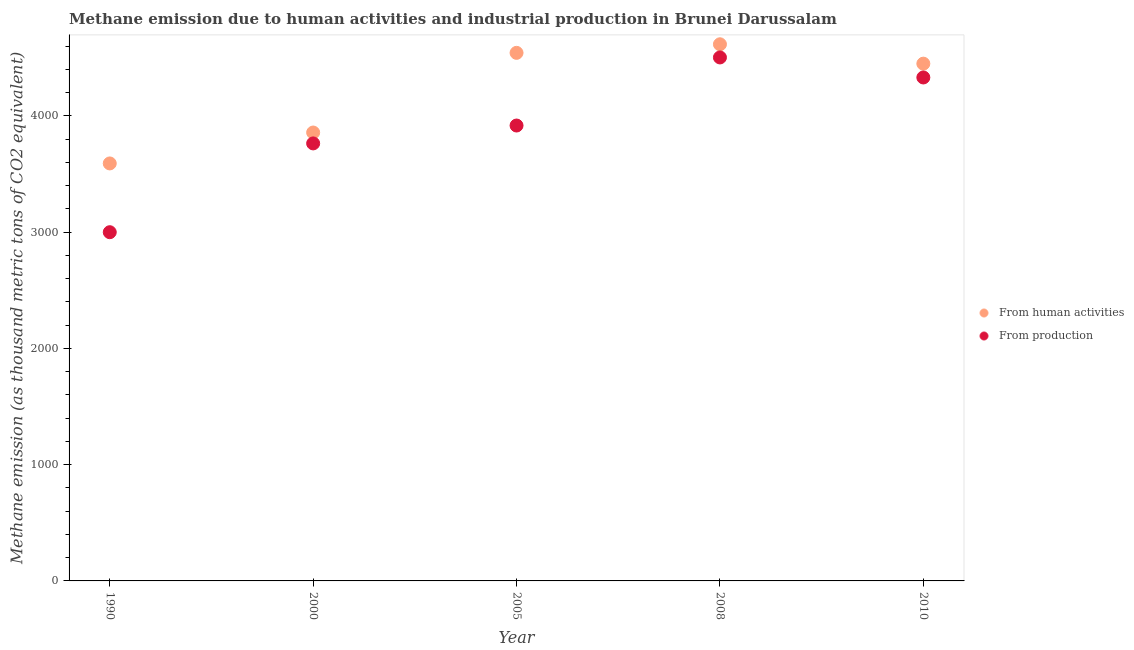How many different coloured dotlines are there?
Your response must be concise. 2. What is the amount of emissions from human activities in 2005?
Your answer should be compact. 4543.3. Across all years, what is the maximum amount of emissions from human activities?
Provide a succinct answer. 4617.1. Across all years, what is the minimum amount of emissions from human activities?
Give a very brief answer. 3591.9. In which year was the amount of emissions from human activities maximum?
Your answer should be very brief. 2008. What is the total amount of emissions generated from industries in the graph?
Offer a very short reply. 1.95e+04. What is the difference between the amount of emissions from human activities in 2000 and that in 2010?
Provide a short and direct response. -592.6. What is the difference between the amount of emissions from human activities in 2010 and the amount of emissions generated from industries in 1990?
Offer a terse response. 1450.2. What is the average amount of emissions from human activities per year?
Your answer should be very brief. 4212.1. In the year 1990, what is the difference between the amount of emissions from human activities and amount of emissions generated from industries?
Make the answer very short. 591.7. What is the ratio of the amount of emissions generated from industries in 2000 to that in 2010?
Provide a succinct answer. 0.87. Is the amount of emissions from human activities in 2000 less than that in 2010?
Provide a short and direct response. Yes. Is the difference between the amount of emissions from human activities in 2000 and 2008 greater than the difference between the amount of emissions generated from industries in 2000 and 2008?
Offer a very short reply. No. What is the difference between the highest and the second highest amount of emissions generated from industries?
Your response must be concise. 172.3. What is the difference between the highest and the lowest amount of emissions from human activities?
Offer a terse response. 1025.2. In how many years, is the amount of emissions generated from industries greater than the average amount of emissions generated from industries taken over all years?
Offer a very short reply. 3. Does the amount of emissions generated from industries monotonically increase over the years?
Provide a succinct answer. No. Is the amount of emissions from human activities strictly greater than the amount of emissions generated from industries over the years?
Keep it short and to the point. Yes. How many dotlines are there?
Your answer should be compact. 2. What is the difference between two consecutive major ticks on the Y-axis?
Your response must be concise. 1000. Does the graph contain grids?
Ensure brevity in your answer.  No. What is the title of the graph?
Offer a very short reply. Methane emission due to human activities and industrial production in Brunei Darussalam. Does "GDP at market prices" appear as one of the legend labels in the graph?
Make the answer very short. No. What is the label or title of the Y-axis?
Keep it short and to the point. Methane emission (as thousand metric tons of CO2 equivalent). What is the Methane emission (as thousand metric tons of CO2 equivalent) in From human activities in 1990?
Offer a terse response. 3591.9. What is the Methane emission (as thousand metric tons of CO2 equivalent) in From production in 1990?
Ensure brevity in your answer.  3000.2. What is the Methane emission (as thousand metric tons of CO2 equivalent) of From human activities in 2000?
Give a very brief answer. 3857.8. What is the Methane emission (as thousand metric tons of CO2 equivalent) in From production in 2000?
Provide a short and direct response. 3764.1. What is the Methane emission (as thousand metric tons of CO2 equivalent) of From human activities in 2005?
Offer a terse response. 4543.3. What is the Methane emission (as thousand metric tons of CO2 equivalent) in From production in 2005?
Make the answer very short. 3918. What is the Methane emission (as thousand metric tons of CO2 equivalent) of From human activities in 2008?
Make the answer very short. 4617.1. What is the Methane emission (as thousand metric tons of CO2 equivalent) of From production in 2008?
Offer a terse response. 4503.7. What is the Methane emission (as thousand metric tons of CO2 equivalent) in From human activities in 2010?
Your answer should be very brief. 4450.4. What is the Methane emission (as thousand metric tons of CO2 equivalent) in From production in 2010?
Give a very brief answer. 4331.4. Across all years, what is the maximum Methane emission (as thousand metric tons of CO2 equivalent) of From human activities?
Your response must be concise. 4617.1. Across all years, what is the maximum Methane emission (as thousand metric tons of CO2 equivalent) of From production?
Ensure brevity in your answer.  4503.7. Across all years, what is the minimum Methane emission (as thousand metric tons of CO2 equivalent) in From human activities?
Offer a very short reply. 3591.9. Across all years, what is the minimum Methane emission (as thousand metric tons of CO2 equivalent) in From production?
Ensure brevity in your answer.  3000.2. What is the total Methane emission (as thousand metric tons of CO2 equivalent) in From human activities in the graph?
Offer a very short reply. 2.11e+04. What is the total Methane emission (as thousand metric tons of CO2 equivalent) of From production in the graph?
Offer a very short reply. 1.95e+04. What is the difference between the Methane emission (as thousand metric tons of CO2 equivalent) of From human activities in 1990 and that in 2000?
Give a very brief answer. -265.9. What is the difference between the Methane emission (as thousand metric tons of CO2 equivalent) of From production in 1990 and that in 2000?
Make the answer very short. -763.9. What is the difference between the Methane emission (as thousand metric tons of CO2 equivalent) in From human activities in 1990 and that in 2005?
Provide a succinct answer. -951.4. What is the difference between the Methane emission (as thousand metric tons of CO2 equivalent) of From production in 1990 and that in 2005?
Make the answer very short. -917.8. What is the difference between the Methane emission (as thousand metric tons of CO2 equivalent) in From human activities in 1990 and that in 2008?
Ensure brevity in your answer.  -1025.2. What is the difference between the Methane emission (as thousand metric tons of CO2 equivalent) in From production in 1990 and that in 2008?
Make the answer very short. -1503.5. What is the difference between the Methane emission (as thousand metric tons of CO2 equivalent) of From human activities in 1990 and that in 2010?
Your response must be concise. -858.5. What is the difference between the Methane emission (as thousand metric tons of CO2 equivalent) in From production in 1990 and that in 2010?
Ensure brevity in your answer.  -1331.2. What is the difference between the Methane emission (as thousand metric tons of CO2 equivalent) of From human activities in 2000 and that in 2005?
Your answer should be compact. -685.5. What is the difference between the Methane emission (as thousand metric tons of CO2 equivalent) of From production in 2000 and that in 2005?
Give a very brief answer. -153.9. What is the difference between the Methane emission (as thousand metric tons of CO2 equivalent) of From human activities in 2000 and that in 2008?
Your answer should be compact. -759.3. What is the difference between the Methane emission (as thousand metric tons of CO2 equivalent) of From production in 2000 and that in 2008?
Provide a short and direct response. -739.6. What is the difference between the Methane emission (as thousand metric tons of CO2 equivalent) of From human activities in 2000 and that in 2010?
Your answer should be compact. -592.6. What is the difference between the Methane emission (as thousand metric tons of CO2 equivalent) of From production in 2000 and that in 2010?
Your answer should be very brief. -567.3. What is the difference between the Methane emission (as thousand metric tons of CO2 equivalent) in From human activities in 2005 and that in 2008?
Provide a short and direct response. -73.8. What is the difference between the Methane emission (as thousand metric tons of CO2 equivalent) in From production in 2005 and that in 2008?
Your answer should be very brief. -585.7. What is the difference between the Methane emission (as thousand metric tons of CO2 equivalent) in From human activities in 2005 and that in 2010?
Make the answer very short. 92.9. What is the difference between the Methane emission (as thousand metric tons of CO2 equivalent) in From production in 2005 and that in 2010?
Offer a very short reply. -413.4. What is the difference between the Methane emission (as thousand metric tons of CO2 equivalent) in From human activities in 2008 and that in 2010?
Make the answer very short. 166.7. What is the difference between the Methane emission (as thousand metric tons of CO2 equivalent) in From production in 2008 and that in 2010?
Your response must be concise. 172.3. What is the difference between the Methane emission (as thousand metric tons of CO2 equivalent) of From human activities in 1990 and the Methane emission (as thousand metric tons of CO2 equivalent) of From production in 2000?
Your response must be concise. -172.2. What is the difference between the Methane emission (as thousand metric tons of CO2 equivalent) of From human activities in 1990 and the Methane emission (as thousand metric tons of CO2 equivalent) of From production in 2005?
Offer a very short reply. -326.1. What is the difference between the Methane emission (as thousand metric tons of CO2 equivalent) in From human activities in 1990 and the Methane emission (as thousand metric tons of CO2 equivalent) in From production in 2008?
Provide a short and direct response. -911.8. What is the difference between the Methane emission (as thousand metric tons of CO2 equivalent) in From human activities in 1990 and the Methane emission (as thousand metric tons of CO2 equivalent) in From production in 2010?
Your answer should be compact. -739.5. What is the difference between the Methane emission (as thousand metric tons of CO2 equivalent) of From human activities in 2000 and the Methane emission (as thousand metric tons of CO2 equivalent) of From production in 2005?
Make the answer very short. -60.2. What is the difference between the Methane emission (as thousand metric tons of CO2 equivalent) of From human activities in 2000 and the Methane emission (as thousand metric tons of CO2 equivalent) of From production in 2008?
Offer a terse response. -645.9. What is the difference between the Methane emission (as thousand metric tons of CO2 equivalent) in From human activities in 2000 and the Methane emission (as thousand metric tons of CO2 equivalent) in From production in 2010?
Ensure brevity in your answer.  -473.6. What is the difference between the Methane emission (as thousand metric tons of CO2 equivalent) of From human activities in 2005 and the Methane emission (as thousand metric tons of CO2 equivalent) of From production in 2008?
Provide a short and direct response. 39.6. What is the difference between the Methane emission (as thousand metric tons of CO2 equivalent) in From human activities in 2005 and the Methane emission (as thousand metric tons of CO2 equivalent) in From production in 2010?
Offer a very short reply. 211.9. What is the difference between the Methane emission (as thousand metric tons of CO2 equivalent) of From human activities in 2008 and the Methane emission (as thousand metric tons of CO2 equivalent) of From production in 2010?
Your answer should be compact. 285.7. What is the average Methane emission (as thousand metric tons of CO2 equivalent) in From human activities per year?
Offer a very short reply. 4212.1. What is the average Methane emission (as thousand metric tons of CO2 equivalent) in From production per year?
Provide a succinct answer. 3903.48. In the year 1990, what is the difference between the Methane emission (as thousand metric tons of CO2 equivalent) of From human activities and Methane emission (as thousand metric tons of CO2 equivalent) of From production?
Provide a succinct answer. 591.7. In the year 2000, what is the difference between the Methane emission (as thousand metric tons of CO2 equivalent) of From human activities and Methane emission (as thousand metric tons of CO2 equivalent) of From production?
Your answer should be compact. 93.7. In the year 2005, what is the difference between the Methane emission (as thousand metric tons of CO2 equivalent) in From human activities and Methane emission (as thousand metric tons of CO2 equivalent) in From production?
Provide a short and direct response. 625.3. In the year 2008, what is the difference between the Methane emission (as thousand metric tons of CO2 equivalent) in From human activities and Methane emission (as thousand metric tons of CO2 equivalent) in From production?
Your response must be concise. 113.4. In the year 2010, what is the difference between the Methane emission (as thousand metric tons of CO2 equivalent) of From human activities and Methane emission (as thousand metric tons of CO2 equivalent) of From production?
Offer a terse response. 119. What is the ratio of the Methane emission (as thousand metric tons of CO2 equivalent) in From human activities in 1990 to that in 2000?
Provide a succinct answer. 0.93. What is the ratio of the Methane emission (as thousand metric tons of CO2 equivalent) in From production in 1990 to that in 2000?
Offer a terse response. 0.8. What is the ratio of the Methane emission (as thousand metric tons of CO2 equivalent) in From human activities in 1990 to that in 2005?
Your answer should be compact. 0.79. What is the ratio of the Methane emission (as thousand metric tons of CO2 equivalent) of From production in 1990 to that in 2005?
Provide a short and direct response. 0.77. What is the ratio of the Methane emission (as thousand metric tons of CO2 equivalent) of From human activities in 1990 to that in 2008?
Provide a short and direct response. 0.78. What is the ratio of the Methane emission (as thousand metric tons of CO2 equivalent) in From production in 1990 to that in 2008?
Make the answer very short. 0.67. What is the ratio of the Methane emission (as thousand metric tons of CO2 equivalent) in From human activities in 1990 to that in 2010?
Your answer should be very brief. 0.81. What is the ratio of the Methane emission (as thousand metric tons of CO2 equivalent) of From production in 1990 to that in 2010?
Your response must be concise. 0.69. What is the ratio of the Methane emission (as thousand metric tons of CO2 equivalent) in From human activities in 2000 to that in 2005?
Offer a very short reply. 0.85. What is the ratio of the Methane emission (as thousand metric tons of CO2 equivalent) in From production in 2000 to that in 2005?
Offer a very short reply. 0.96. What is the ratio of the Methane emission (as thousand metric tons of CO2 equivalent) of From human activities in 2000 to that in 2008?
Offer a terse response. 0.84. What is the ratio of the Methane emission (as thousand metric tons of CO2 equivalent) in From production in 2000 to that in 2008?
Provide a short and direct response. 0.84. What is the ratio of the Methane emission (as thousand metric tons of CO2 equivalent) in From human activities in 2000 to that in 2010?
Give a very brief answer. 0.87. What is the ratio of the Methane emission (as thousand metric tons of CO2 equivalent) in From production in 2000 to that in 2010?
Offer a terse response. 0.87. What is the ratio of the Methane emission (as thousand metric tons of CO2 equivalent) in From production in 2005 to that in 2008?
Offer a very short reply. 0.87. What is the ratio of the Methane emission (as thousand metric tons of CO2 equivalent) of From human activities in 2005 to that in 2010?
Offer a very short reply. 1.02. What is the ratio of the Methane emission (as thousand metric tons of CO2 equivalent) of From production in 2005 to that in 2010?
Your answer should be compact. 0.9. What is the ratio of the Methane emission (as thousand metric tons of CO2 equivalent) in From human activities in 2008 to that in 2010?
Your answer should be very brief. 1.04. What is the ratio of the Methane emission (as thousand metric tons of CO2 equivalent) of From production in 2008 to that in 2010?
Your answer should be compact. 1.04. What is the difference between the highest and the second highest Methane emission (as thousand metric tons of CO2 equivalent) of From human activities?
Make the answer very short. 73.8. What is the difference between the highest and the second highest Methane emission (as thousand metric tons of CO2 equivalent) in From production?
Provide a short and direct response. 172.3. What is the difference between the highest and the lowest Methane emission (as thousand metric tons of CO2 equivalent) in From human activities?
Provide a short and direct response. 1025.2. What is the difference between the highest and the lowest Methane emission (as thousand metric tons of CO2 equivalent) of From production?
Give a very brief answer. 1503.5. 